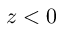Convert formula to latex. <formula><loc_0><loc_0><loc_500><loc_500>z < 0</formula> 